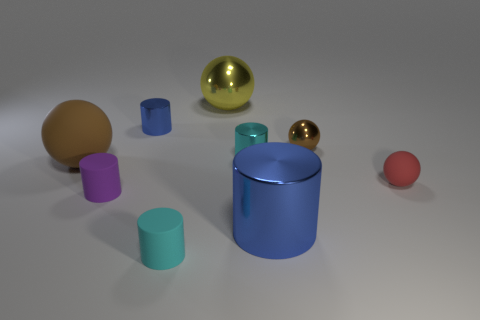What color is the tiny sphere that is made of the same material as the large blue object?
Provide a short and direct response. Brown. What number of matte objects are either spheres or gray cubes?
Ensure brevity in your answer.  2. There is a brown object that is the same size as the red rubber thing; what is its shape?
Offer a terse response. Sphere. What number of things are either small objects that are to the right of the small purple object or cylinders behind the brown rubber sphere?
Your answer should be compact. 5. There is another cyan thing that is the same size as the cyan rubber thing; what is it made of?
Ensure brevity in your answer.  Metal. What number of other things are there of the same material as the tiny brown object
Provide a succinct answer. 4. Are there the same number of large blue metal objects that are behind the big blue thing and brown shiny objects that are on the right side of the cyan rubber object?
Provide a succinct answer. No. What number of cyan objects are either small matte cylinders or small objects?
Your answer should be very brief. 2. Does the big cylinder have the same color as the metallic sphere in front of the yellow thing?
Ensure brevity in your answer.  No. How many other objects are the same color as the big matte sphere?
Give a very brief answer. 1. 